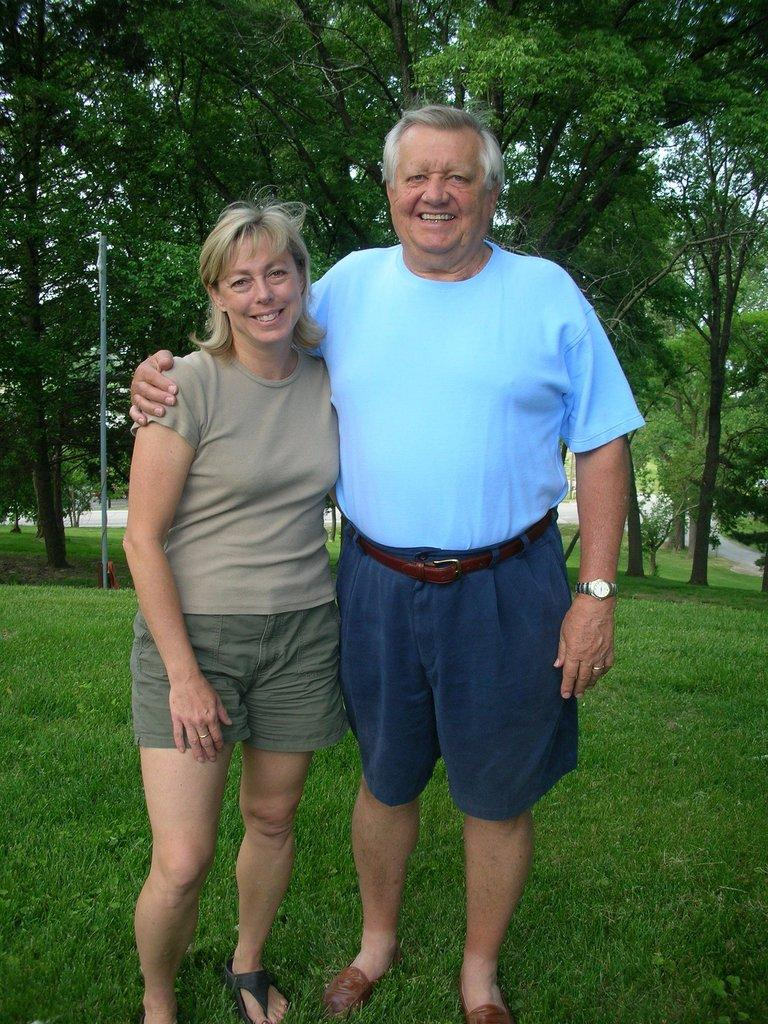How many people are present in the image? There are two people, a man and a woman, present in the image. What are the man and the woman doing in the image? Both the man and the woman are standing on the grass and smiling. What can be seen in the background of the image? There is a pole, a path, and trees in the background of the image. What type of vegetable is the man holding in the image? There is no vegetable present in the image; the man is not holding anything. How many arms does the woman have in the image? The woman has two arms in the image, just like any other person. 